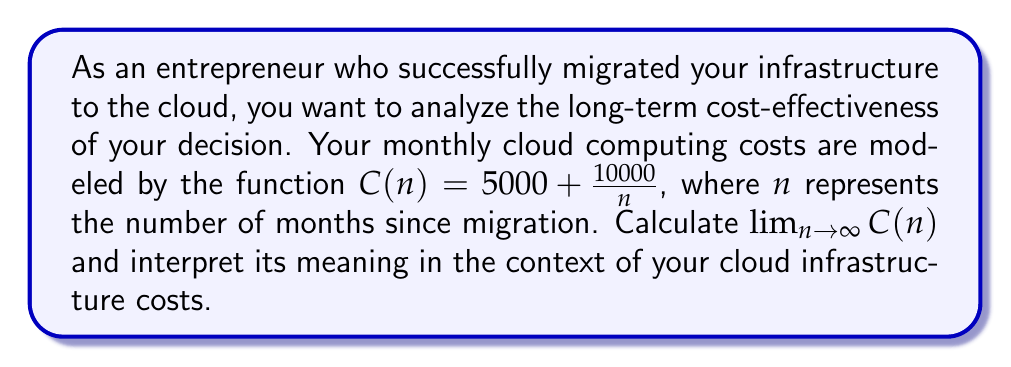Solve this math problem. To solve this problem, we'll use the limit theorem for rational functions. Let's break it down step-by-step:

1) The given function is $C(n) = 5000 + \frac{10000}{n}$

2) To find the limit as $n$ approaches infinity, we need to evaluate:

   $$\lim_{n \to \infty} (5000 + \frac{10000}{n})$$

3) We can separate this limit into two parts:

   $$\lim_{n \to \infty} 5000 + \lim_{n \to \infty} \frac{10000}{n}$$

4) The first part is straightforward:

   $$\lim_{n \to \infty} 5000 = 5000$$

   This is because 5000 is a constant and doesn't depend on $n$.

5) For the second part:

   $$\lim_{n \to \infty} \frac{10000}{n}$$

   As $n$ approaches infinity, this fraction approaches 0, because the numerator is constant while the denominator grows infinitely large.

6) Therefore:

   $$\lim_{n \to \infty} \frac{10000}{n} = 0$$

7) Combining the results from steps 4 and 6:

   $$\lim_{n \to \infty} (5000 + \frac{10000}{n}) = 5000 + 0 = 5000$$

Interpretation: This limit represents the long-term monthly cost of your cloud infrastructure. As time goes on (n increases), your monthly cost approaches $5000. This suggests that while there may be some initial variation or higher costs, in the long run, your monthly cloud computing expenses stabilize at $5000.
Answer: $\lim_{n \to \infty} C(n) = 5000$ 